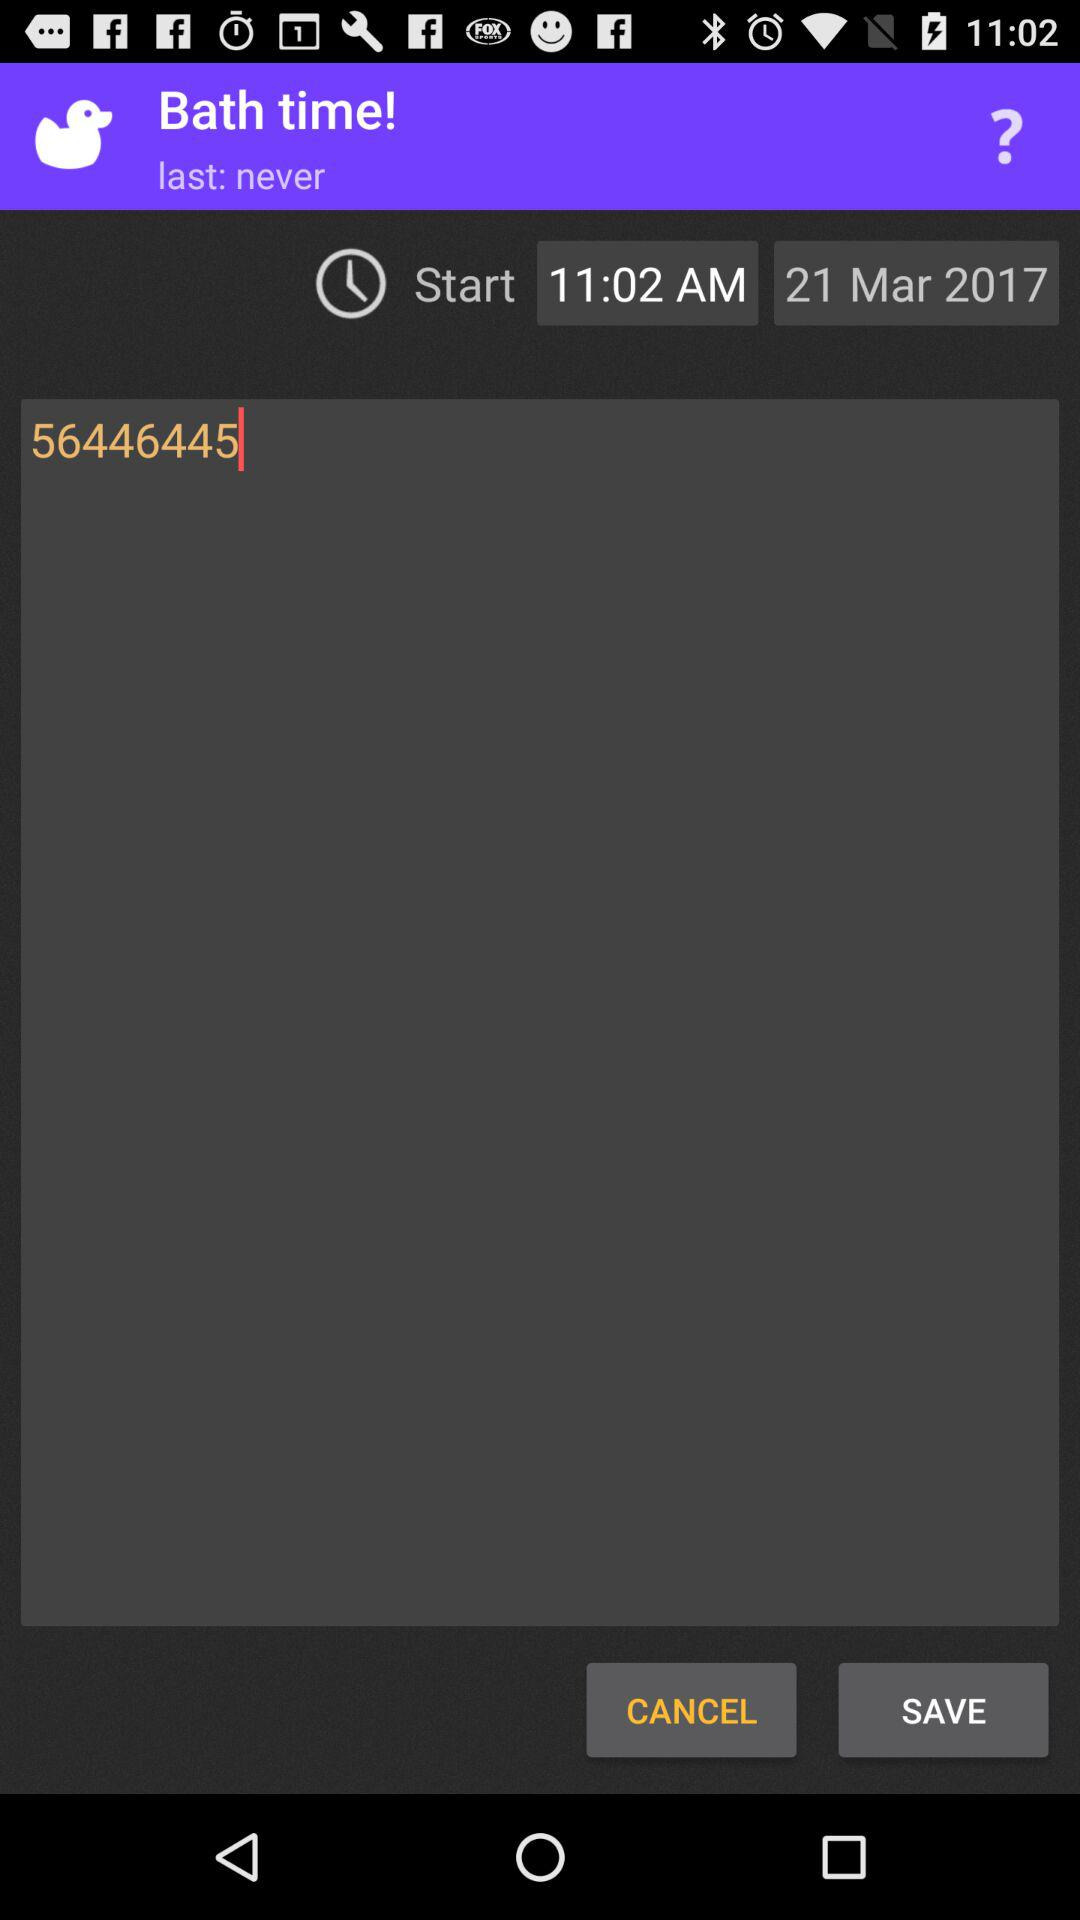What time is selected for bath? The selected time is 11:02 AM. 